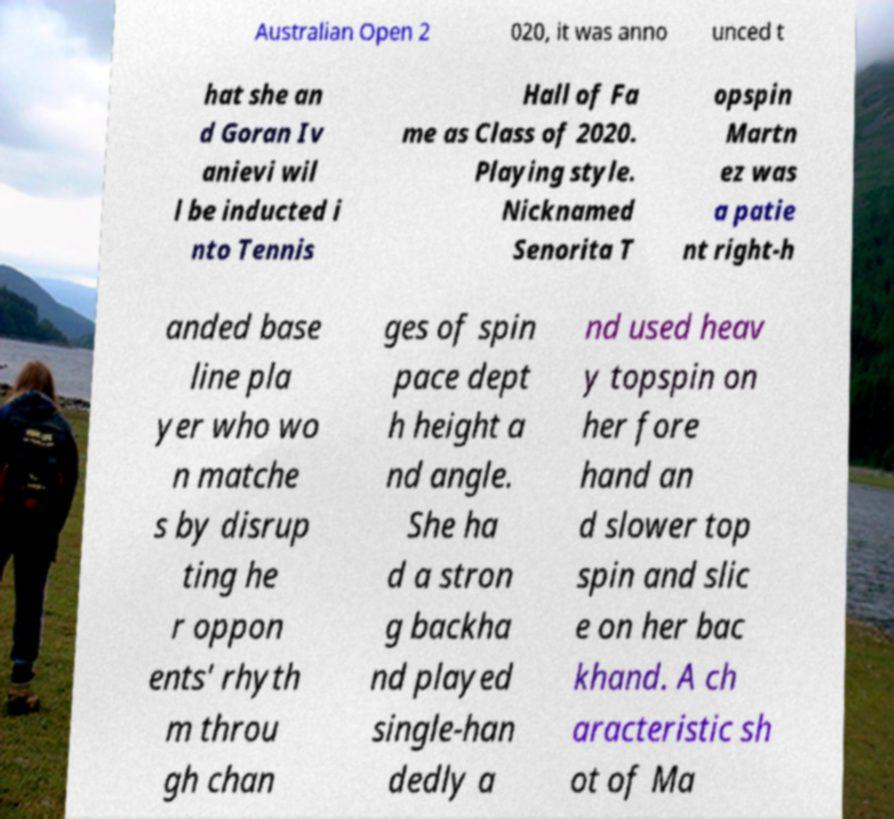There's text embedded in this image that I need extracted. Can you transcribe it verbatim? Australian Open 2 020, it was anno unced t hat she an d Goran Iv anievi wil l be inducted i nto Tennis Hall of Fa me as Class of 2020. Playing style. Nicknamed Senorita T opspin Martn ez was a patie nt right-h anded base line pla yer who wo n matche s by disrup ting he r oppon ents' rhyth m throu gh chan ges of spin pace dept h height a nd angle. She ha d a stron g backha nd played single-han dedly a nd used heav y topspin on her fore hand an d slower top spin and slic e on her bac khand. A ch aracteristic sh ot of Ma 